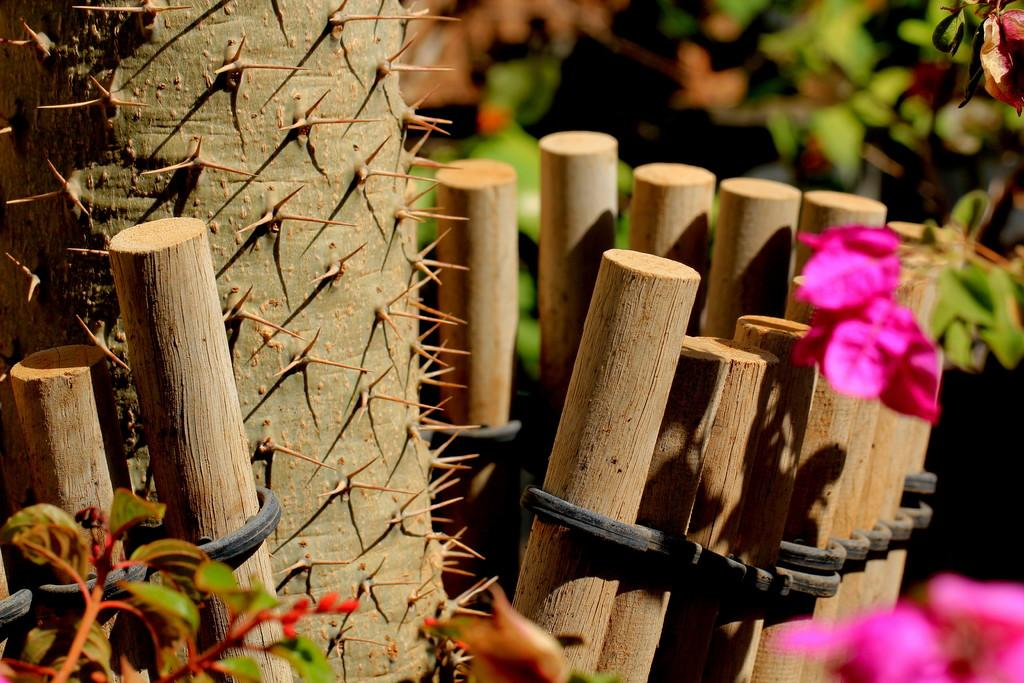What type of living organisms can be seen in the image? There are flowers and plants visible in the image. What objects are made of wood in the image? There are wooden sticks in the image. What type of sharp objects are present in the image? There are spikes in the image. How would you describe the background of the image? The background of the image is blurry. Can you see any bananas growing on the plants in the image? There are no bananas present in the image; it features flowers and plants. Are there any snails crawling on the wooden sticks in the image? There are no snails visible in the image. 